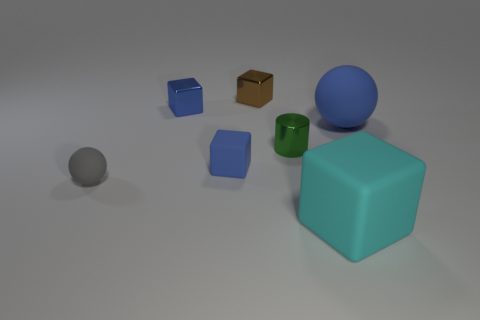Subtract all tiny brown metallic cubes. How many cubes are left? 3 Subtract all cyan cylinders. How many blue cubes are left? 2 Subtract all brown blocks. How many blocks are left? 3 Subtract 1 cubes. How many cubes are left? 3 Add 2 tiny rubber cylinders. How many objects exist? 9 Subtract all yellow blocks. Subtract all blue spheres. How many blocks are left? 4 Subtract all spheres. How many objects are left? 5 Subtract all red metal spheres. Subtract all small blue rubber objects. How many objects are left? 6 Add 4 cyan blocks. How many cyan blocks are left? 5 Add 1 tiny matte cylinders. How many tiny matte cylinders exist? 1 